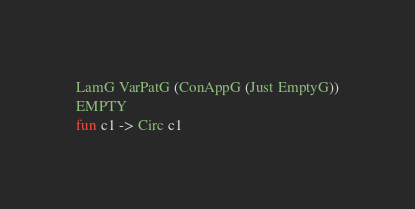<code> <loc_0><loc_0><loc_500><loc_500><_OCaml_>LamG VarPatG (ConAppG (Just EmptyG))
EMPTY
fun c1 -> Circ c1
</code> 